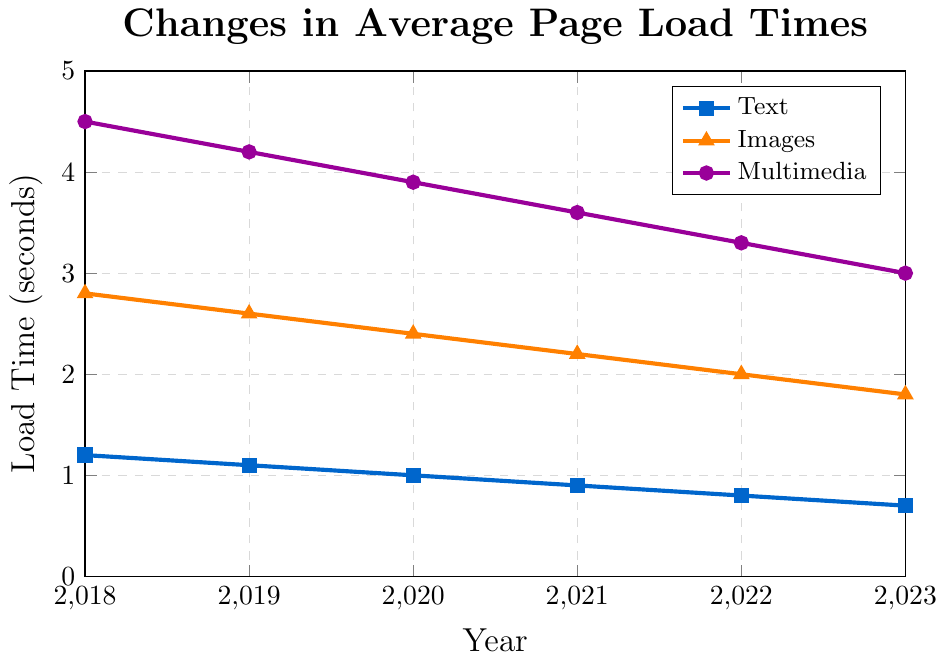What was the average page load time for websites containing images in 2020? To find the average page load time for websites with images in 2020, we directly look at the value for images in the year 2020 from the figure.
Answer: 2.4 seconds Between which two years did the page load time for multimedia content decrease by 0.3 seconds? To determine the years, we review the decrease in page load times for multimedia content and identify the years where the difference is 0.3 seconds. The difference 4.2 - 3.9 happens between 2019 and 2020.
Answer: 2019 and 2020 Which content type showed the most significant improvement in page load time from 2018 to 2023? We calculate the differences in load time between 2018 and 2023 for all content types: Text (1.2 - 0.7 = 0.5), Images (2.8 - 1.8 = 1.0), Multimedia (4.5 - 3.0 = 1.5). The largest improvement is for multimedia content.
Answer: Multimedia In 2021, was the page load time for text faster than for images? By how much? We compare the load times for text (0.9 seconds) and images (2.2 seconds) in 2021. The difference is found by subtracting the text load time from the image load time: 2.2 - 0.9.
Answer: Yes, by 1.3 seconds What is the trend of page load times for text content over the 5-year period? Observing the plot for text content, we see the values decrease each year, indicating a consistent downward trend in the page load times.
Answer: Downward trend How much did the page load time for images decrease in total from 2018 to 2023? We subtract the page load time for images in 2023 (1.8 seconds) from that in 2018 (2.8 seconds) to find the total decrease: 2.8 - 1.8.
Answer: 1.0 seconds By what percentage did the page load time for multimedia content decrease from 2018 to 2023? The initial load time in 2018 is 4.5 seconds, and the final in 2023 is 3.0 seconds. The change in time is 4.5 - 3.0 = 1.5 seconds. The percentage decrease is (1.5 / 4.5) * 100.
Answer: 33.33% What was the difference in page load times between text and multimedia content in 2023? We find the load times for text and multimedia in 2023 and subtract the text load time from the multimedia load time: 3.0 - 0.7.
Answer: 2.3 seconds 